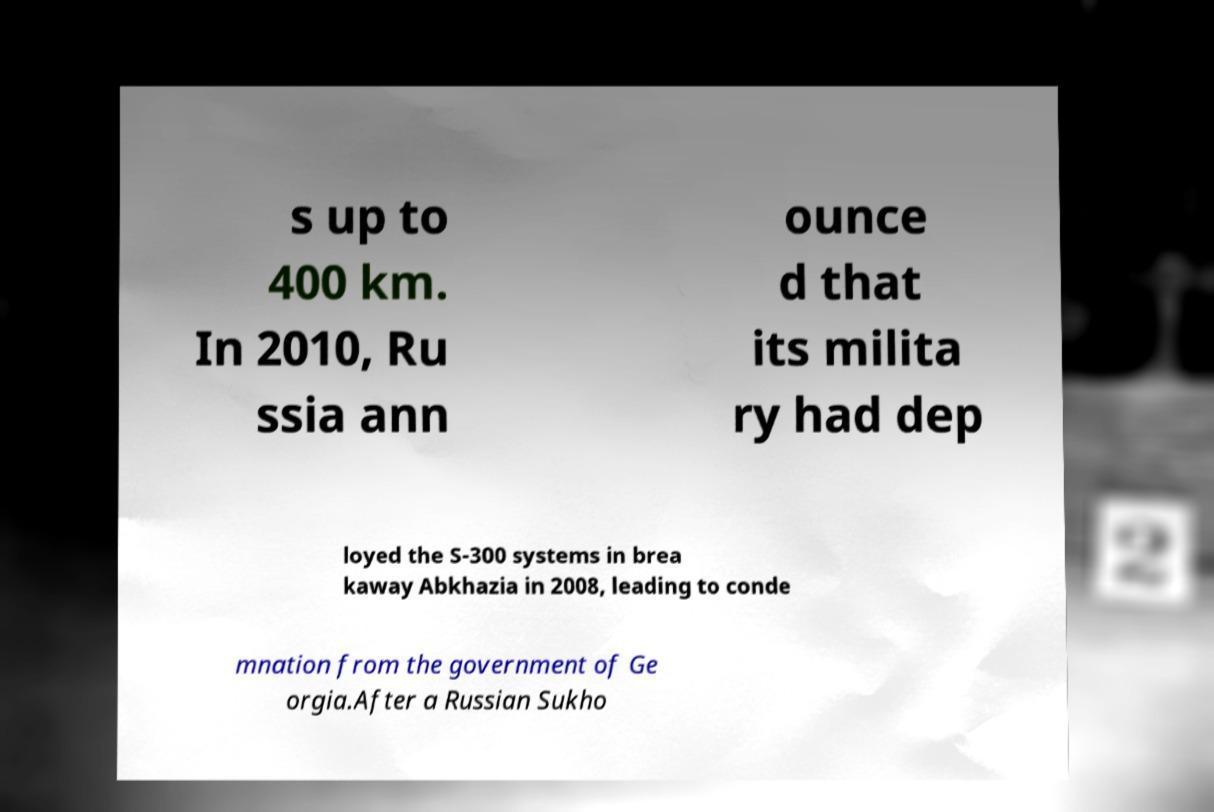Could you assist in decoding the text presented in this image and type it out clearly? s up to 400 km. In 2010, Ru ssia ann ounce d that its milita ry had dep loyed the S-300 systems in brea kaway Abkhazia in 2008, leading to conde mnation from the government of Ge orgia.After a Russian Sukho 